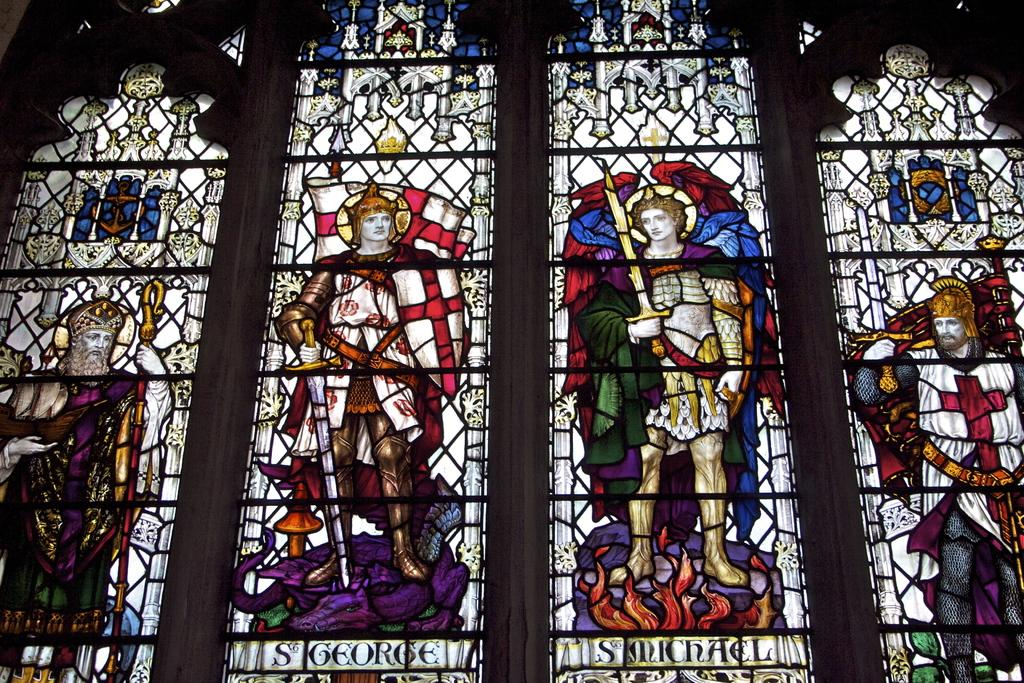What type of glass is present in the image? The image contains stained glass. What is written or depicted on the stained glass? There is text written on the stained glass. How many bananas can be seen hanging from the stained glass in the image? There are no bananas present in the image; it features stained glass with text. What type of metal is visible in the stained glass in the image? There is no metal, such as silver, visible in the stained glass in the image. 